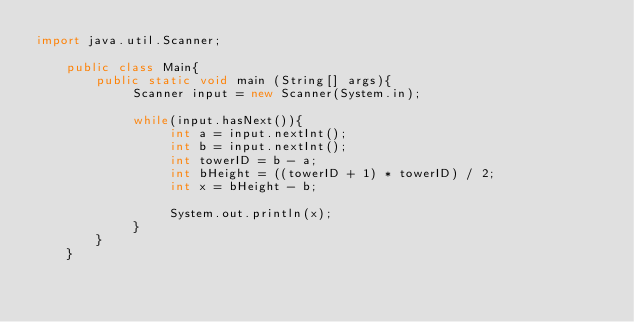Convert code to text. <code><loc_0><loc_0><loc_500><loc_500><_Java_>import java.util.Scanner;
     
    public class Main{
        public static void main (String[] args){
             Scanner input = new Scanner(System.in);
           
             while(input.hasNext()){
                  int a = input.nextInt();
                  int b = input.nextInt();
                  int towerID = b - a;
                  int bHeight = ((towerID + 1) * towerID) / 2;
                  int x = bHeight - b;
                  
                  System.out.println(x);
             }
        }
    }</code> 